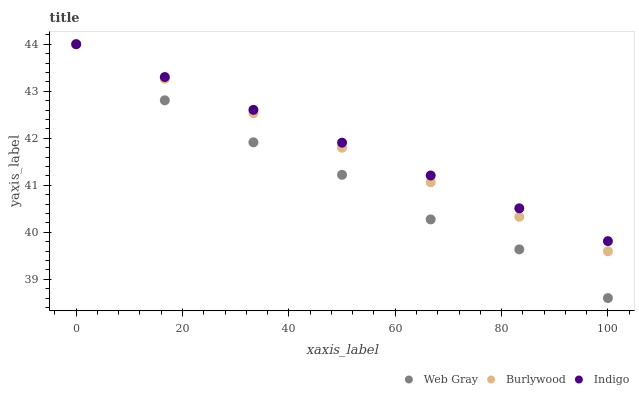Does Web Gray have the minimum area under the curve?
Answer yes or no. Yes. Does Indigo have the maximum area under the curve?
Answer yes or no. Yes. Does Indigo have the minimum area under the curve?
Answer yes or no. No. Does Web Gray have the maximum area under the curve?
Answer yes or no. No. Is Indigo the smoothest?
Answer yes or no. Yes. Is Web Gray the roughest?
Answer yes or no. Yes. Is Web Gray the smoothest?
Answer yes or no. No. Is Indigo the roughest?
Answer yes or no. No. Does Web Gray have the lowest value?
Answer yes or no. Yes. Does Indigo have the lowest value?
Answer yes or no. No. Does Indigo have the highest value?
Answer yes or no. Yes. Does Web Gray intersect Indigo?
Answer yes or no. Yes. Is Web Gray less than Indigo?
Answer yes or no. No. Is Web Gray greater than Indigo?
Answer yes or no. No. 